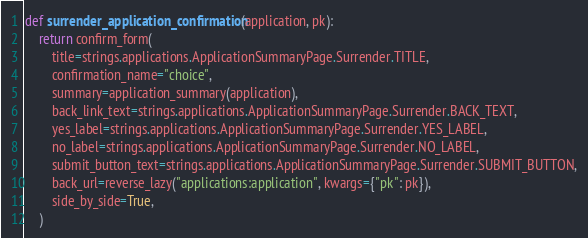Convert code to text. <code><loc_0><loc_0><loc_500><loc_500><_Python_>def surrender_application_confirmation(application, pk):
    return confirm_form(
        title=strings.applications.ApplicationSummaryPage.Surrender.TITLE,
        confirmation_name="choice",
        summary=application_summary(application),
        back_link_text=strings.applications.ApplicationSummaryPage.Surrender.BACK_TEXT,
        yes_label=strings.applications.ApplicationSummaryPage.Surrender.YES_LABEL,
        no_label=strings.applications.ApplicationSummaryPage.Surrender.NO_LABEL,
        submit_button_text=strings.applications.ApplicationSummaryPage.Surrender.SUBMIT_BUTTON,
        back_url=reverse_lazy("applications:application", kwargs={"pk": pk}),
        side_by_side=True,
    )
</code> 